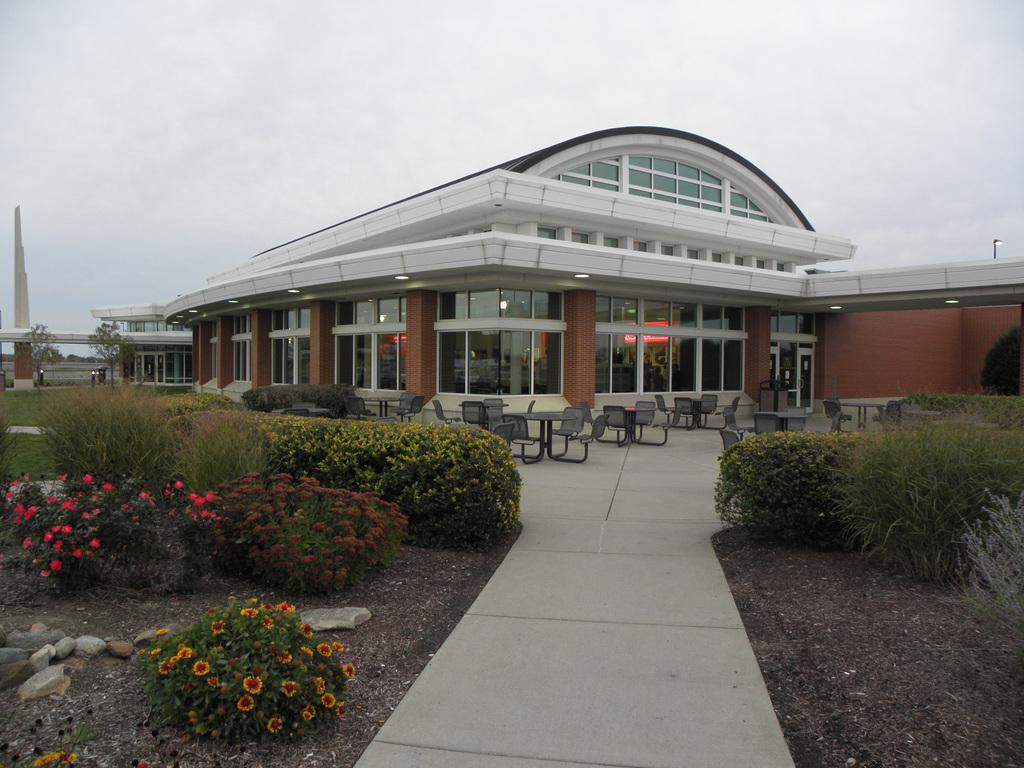What type of pathway can be seen in the image? There is a walkway in the image. What type of vegetation is present in the image? Plants, grass, and trees are present in the image. What type of seating is available in the image? Chairs and tables are in the image. What type of structures are visible in the image? Buildings are in the image. What is the condition of the sky in the image? The sky is visible behind the buildings, and it is cloudy. How many yams are being used as a curtain in the image? There are no yams or curtains present in the image. What type of dogs can be seen playing with the chairs in the image? There are no dogs present in the image. 